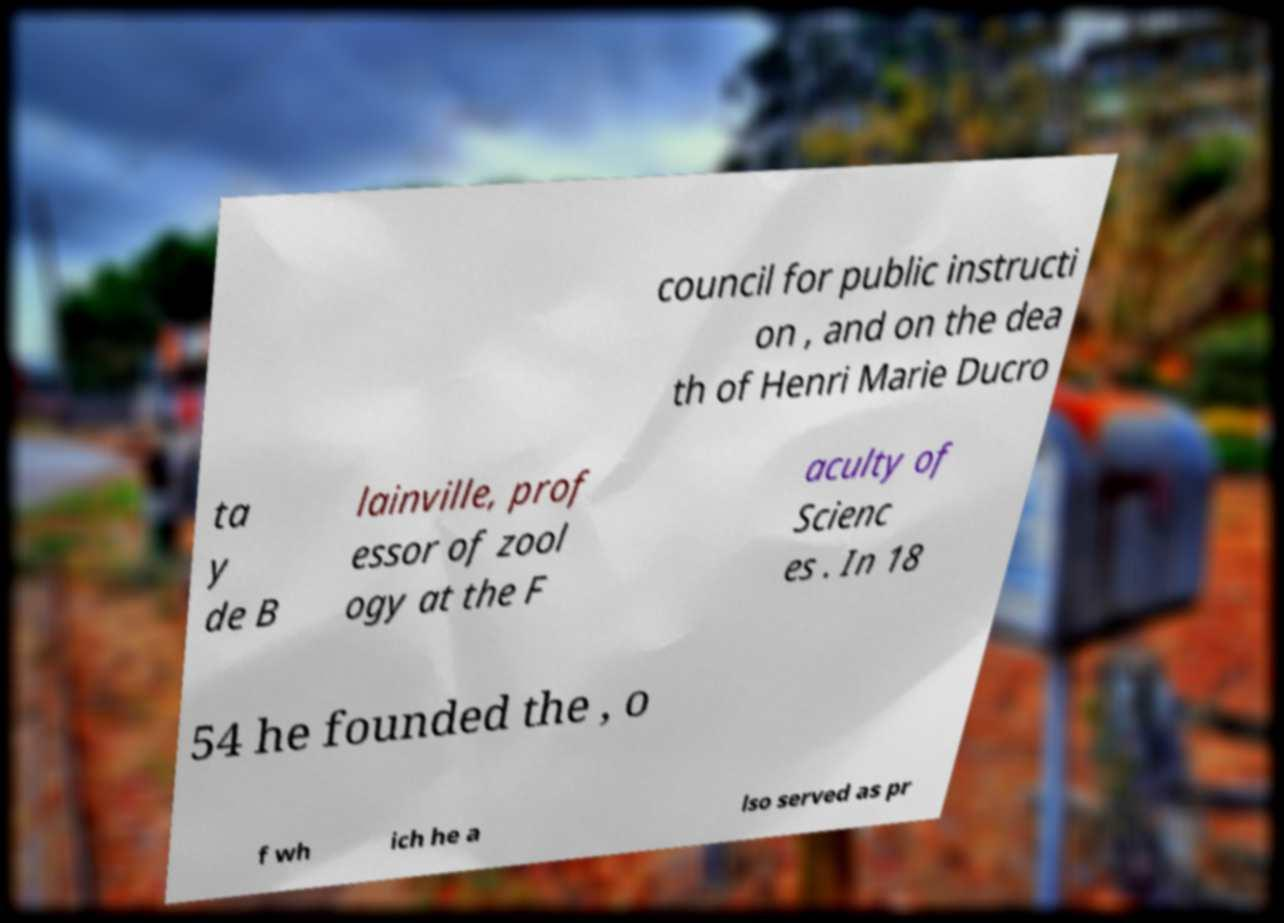Can you accurately transcribe the text from the provided image for me? council for public instructi on , and on the dea th of Henri Marie Ducro ta y de B lainville, prof essor of zool ogy at the F aculty of Scienc es . In 18 54 he founded the , o f wh ich he a lso served as pr 